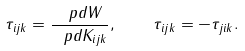<formula> <loc_0><loc_0><loc_500><loc_500>\tau _ { i j k } = \frac { \ p d W } { \ p d K _ { i j k } } , \quad \tau _ { i j k } = - \tau _ { j i k } .</formula> 